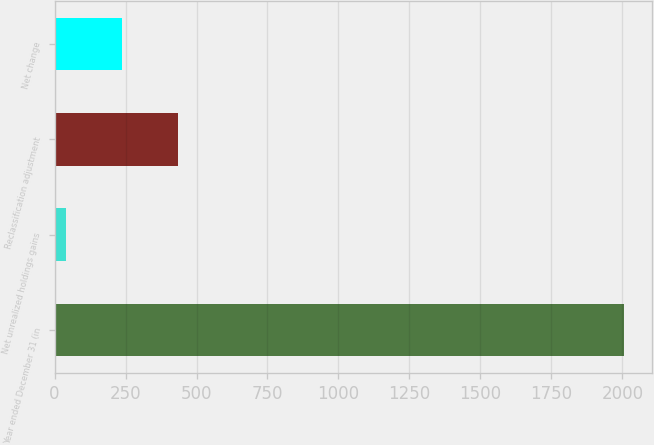Convert chart to OTSL. <chart><loc_0><loc_0><loc_500><loc_500><bar_chart><fcel>Year ended December 31 (in<fcel>Net unrealized holdings gains<fcel>Reclassification adjustment<fcel>Net change<nl><fcel>2004<fcel>41<fcel>433.6<fcel>237.3<nl></chart> 